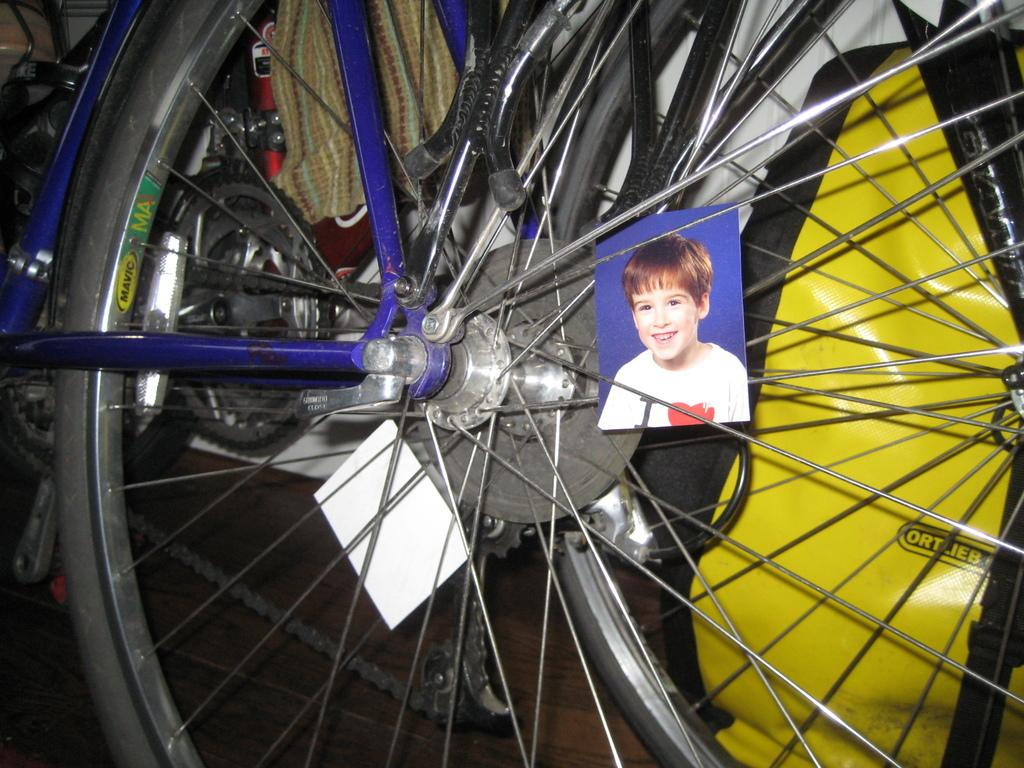What is the main object in the image? There is a bicycle wheel with many spokes in the image. Is there any other object or person in the image? Yes, there is a passport size photo of a boy in the image. How is the boy in the photo depicted? The boy in the photo is smiling. How many brothers does the boy in the photo have, and what color is the bucket they are using? There is no information about the boy's brothers or a bucket in the image. 